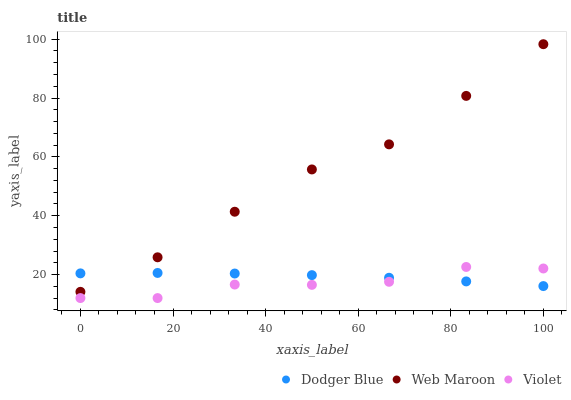Does Violet have the minimum area under the curve?
Answer yes or no. Yes. Does Web Maroon have the maximum area under the curve?
Answer yes or no. Yes. Does Dodger Blue have the minimum area under the curve?
Answer yes or no. No. Does Dodger Blue have the maximum area under the curve?
Answer yes or no. No. Is Dodger Blue the smoothest?
Answer yes or no. Yes. Is Violet the roughest?
Answer yes or no. Yes. Is Violet the smoothest?
Answer yes or no. No. Is Dodger Blue the roughest?
Answer yes or no. No. Does Violet have the lowest value?
Answer yes or no. Yes. Does Dodger Blue have the lowest value?
Answer yes or no. No. Does Web Maroon have the highest value?
Answer yes or no. Yes. Does Violet have the highest value?
Answer yes or no. No. Is Violet less than Web Maroon?
Answer yes or no. Yes. Is Web Maroon greater than Violet?
Answer yes or no. Yes. Does Web Maroon intersect Dodger Blue?
Answer yes or no. Yes. Is Web Maroon less than Dodger Blue?
Answer yes or no. No. Is Web Maroon greater than Dodger Blue?
Answer yes or no. No. Does Violet intersect Web Maroon?
Answer yes or no. No. 